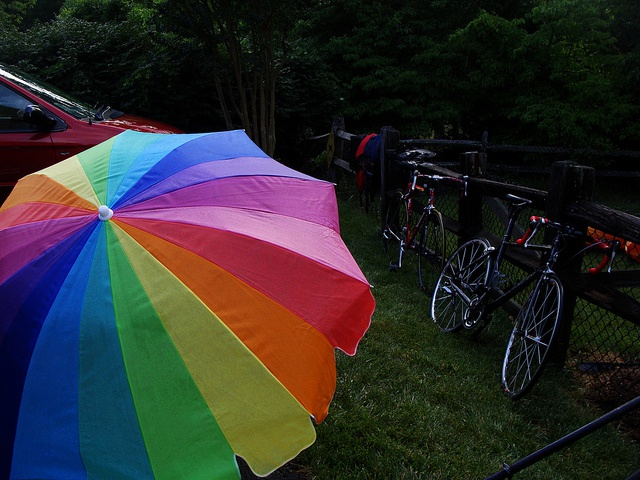Describe the objects in this image and their specific colors. I can see umbrella in black, navy, brown, olive, and darkgreen tones, bicycle in black, navy, gray, and blue tones, car in black, maroon, navy, and purple tones, and bicycle in black, gray, navy, and maroon tones in this image. 